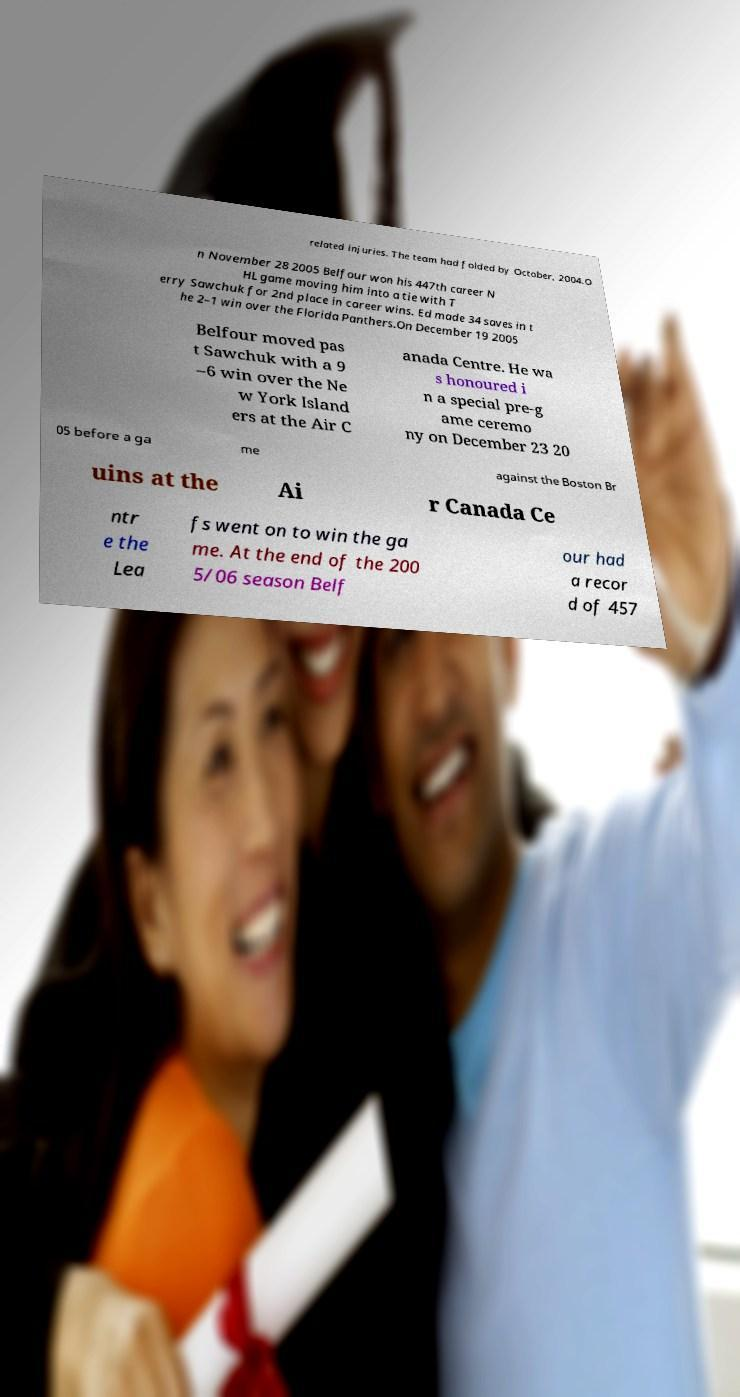What messages or text are displayed in this image? I need them in a readable, typed format. related injuries. The team had folded by October, 2004.O n November 28 2005 Belfour won his 447th career N HL game moving him into a tie with T erry Sawchuk for 2nd place in career wins. Ed made 34 saves in t he 2–1 win over the Florida Panthers.On December 19 2005 Belfour moved pas t Sawchuk with a 9 –6 win over the Ne w York Island ers at the Air C anada Centre. He wa s honoured i n a special pre-g ame ceremo ny on December 23 20 05 before a ga me against the Boston Br uins at the Ai r Canada Ce ntr e the Lea fs went on to win the ga me. At the end of the 200 5/06 season Belf our had a recor d of 457 